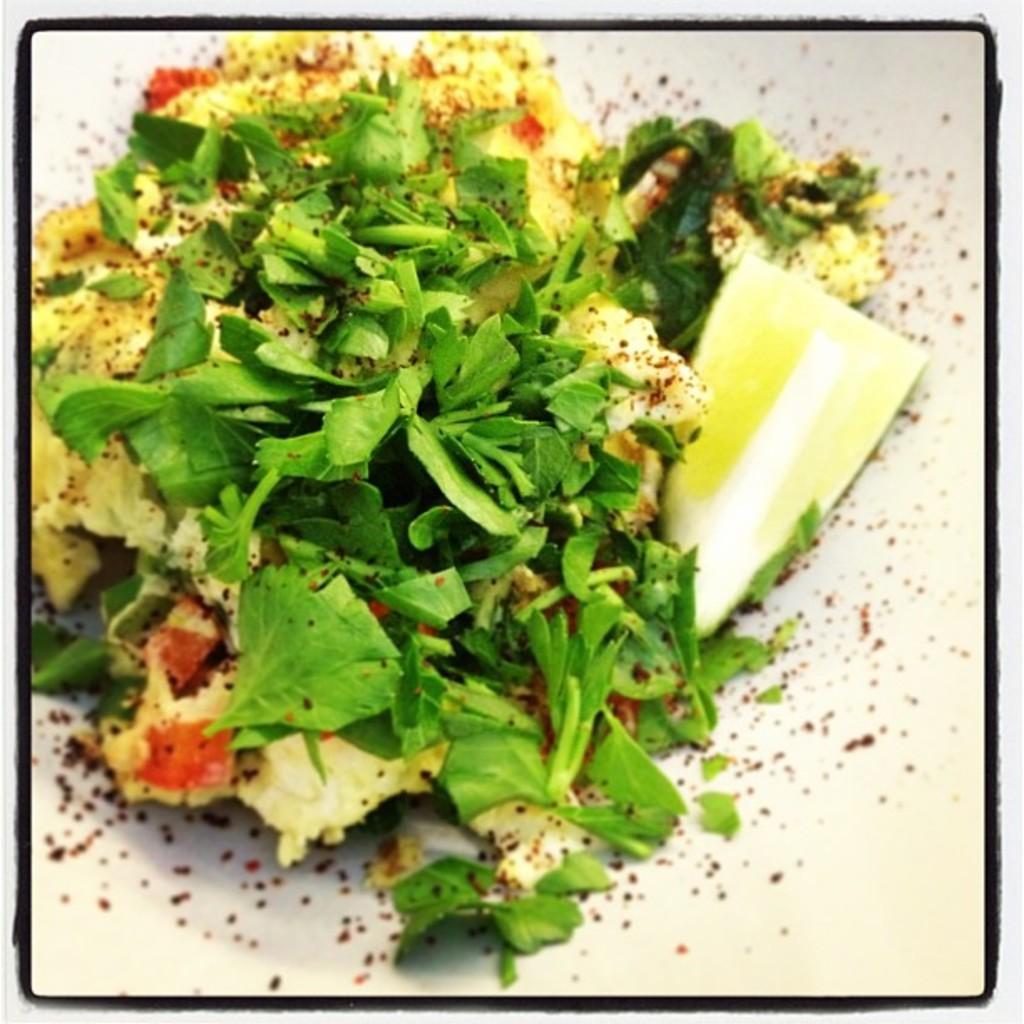Please provide a concise description of this image. This picture contains green leafy vegetables and other food items in the image. 